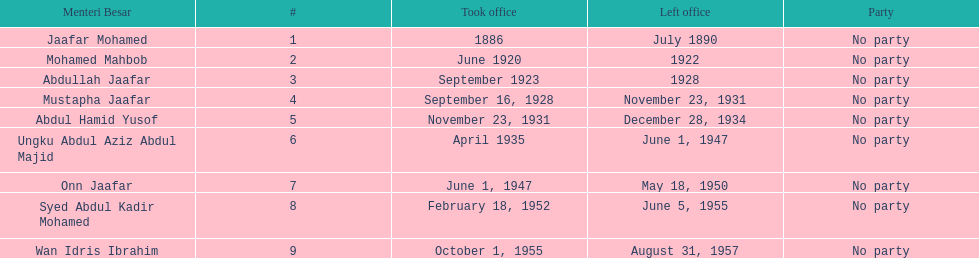Which menteri besars took office in the 1920's? Mohamed Mahbob, Abdullah Jaafar, Mustapha Jaafar. Of those men, who was only in office for 2 years? Mohamed Mahbob. 